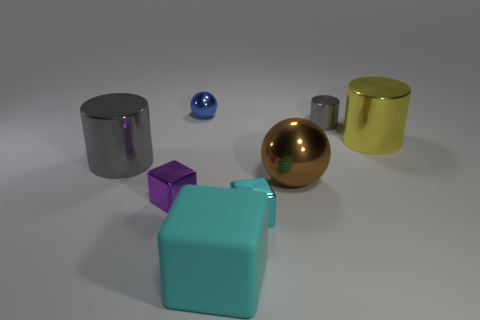What might be the purpose of these objects and the setting they are in? These objects could be part of a 3D rendering or graphic design project, used either for visualizations in product design or as assets in a digital art composition. The setting appears to be a neutral, nondescript space with soft lighting that highlights the objects' shapes and materials without any real-world distractions. This setup is often used to focus attention on the objects themselves for demonstration or educational purposes. 